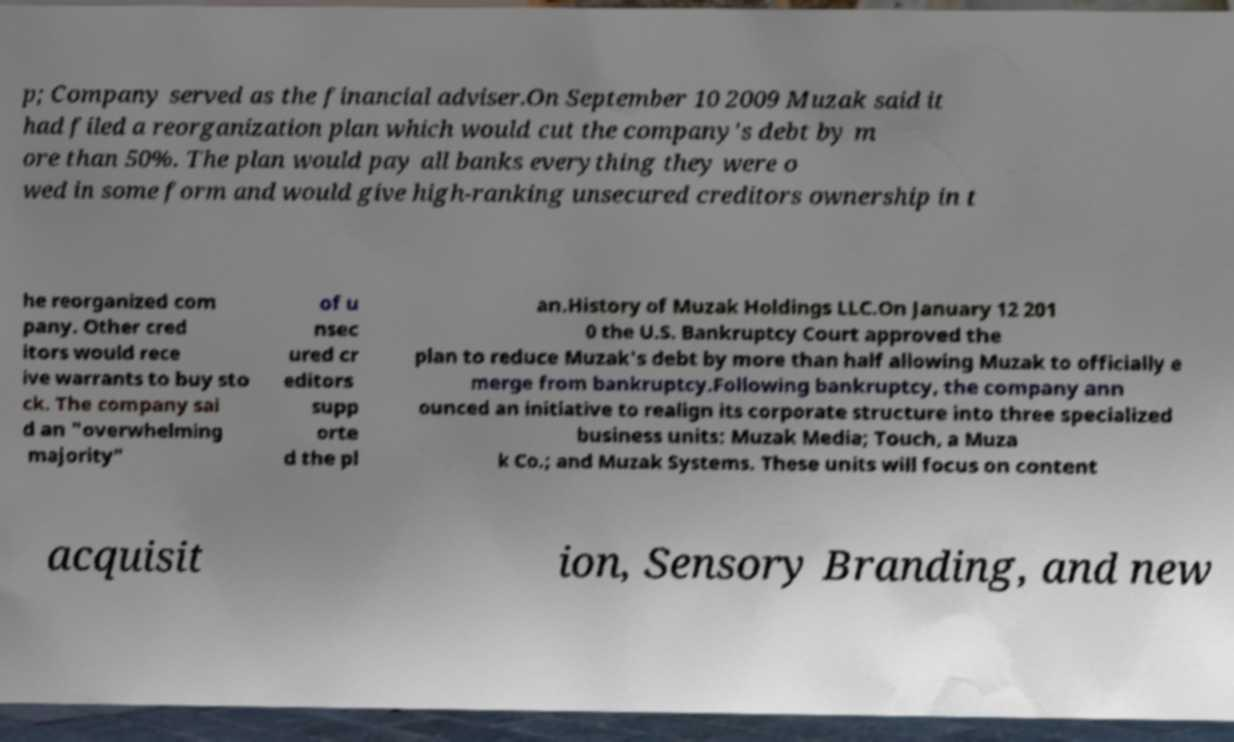Please identify and transcribe the text found in this image. p; Company served as the financial adviser.On September 10 2009 Muzak said it had filed a reorganization plan which would cut the company's debt by m ore than 50%. The plan would pay all banks everything they were o wed in some form and would give high-ranking unsecured creditors ownership in t he reorganized com pany. Other cred itors would rece ive warrants to buy sto ck. The company sai d an "overwhelming majority" of u nsec ured cr editors supp orte d the pl an.History of Muzak Holdings LLC.On January 12 201 0 the U.S. Bankruptcy Court approved the plan to reduce Muzak's debt by more than half allowing Muzak to officially e merge from bankruptcy.Following bankruptcy, the company ann ounced an initiative to realign its corporate structure into three specialized business units: Muzak Media; Touch, a Muza k Co.; and Muzak Systems. These units will focus on content acquisit ion, Sensory Branding, and new 